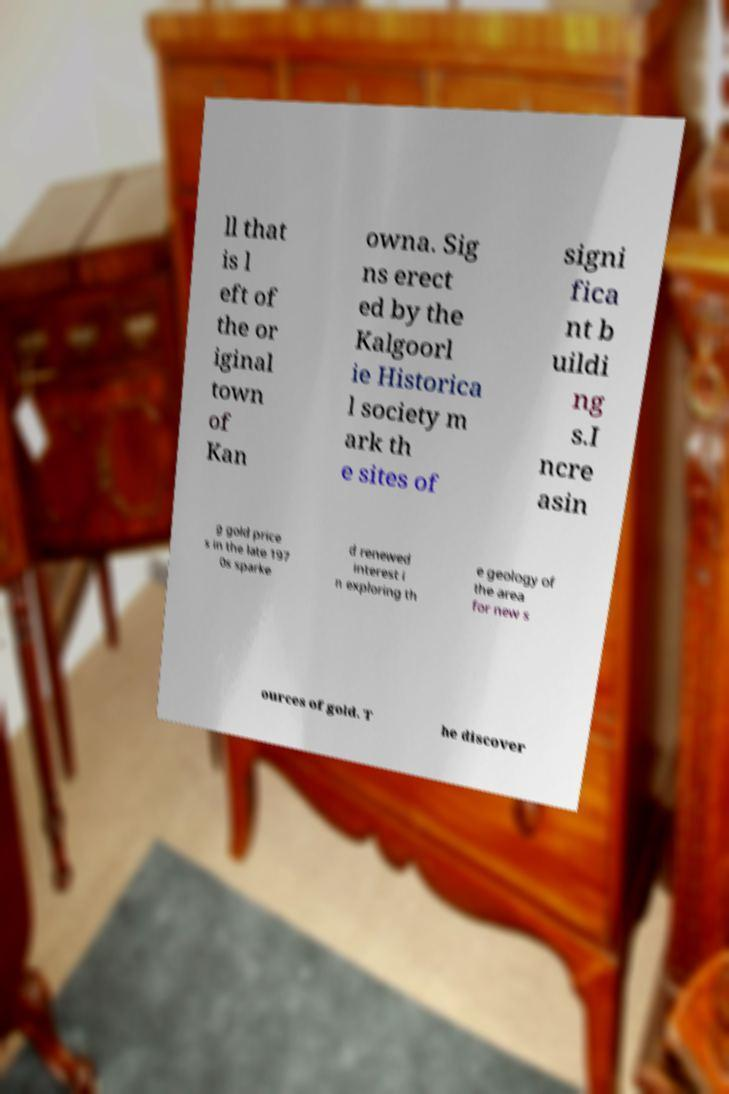What messages or text are displayed in this image? I need them in a readable, typed format. ll that is l eft of the or iginal town of Kan owna. Sig ns erect ed by the Kalgoorl ie Historica l society m ark th e sites of signi fica nt b uildi ng s.I ncre asin g gold price s in the late 197 0s sparke d renewed interest i n exploring th e geology of the area for new s ources of gold. T he discover 